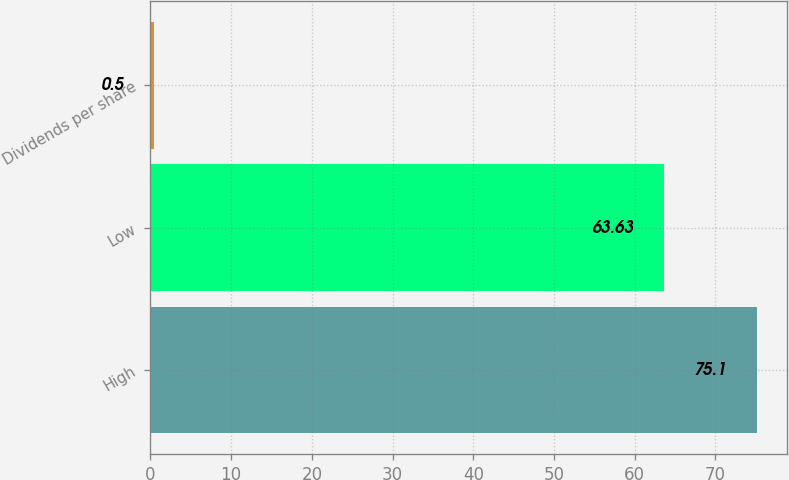Convert chart to OTSL. <chart><loc_0><loc_0><loc_500><loc_500><bar_chart><fcel>High<fcel>Low<fcel>Dividends per share<nl><fcel>75.1<fcel>63.63<fcel>0.5<nl></chart> 